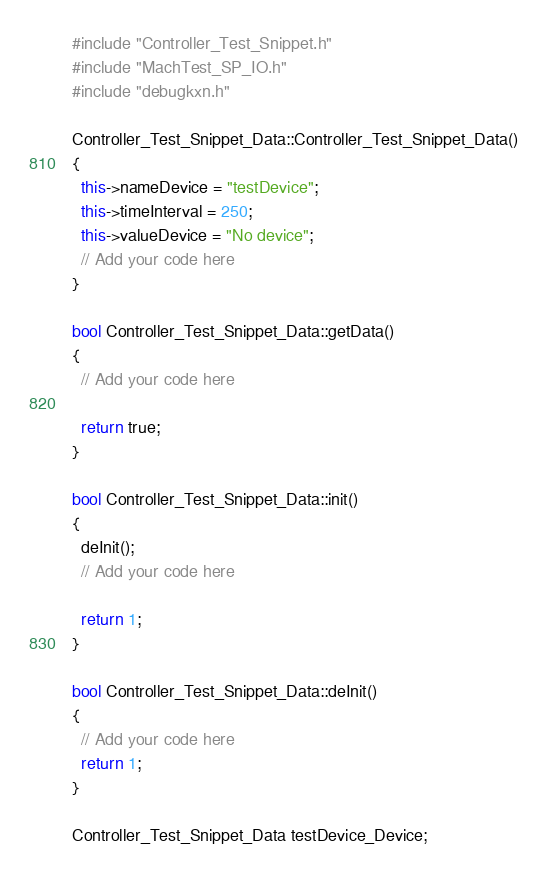<code> <loc_0><loc_0><loc_500><loc_500><_C++_>#include "Controller_Test_Snippet.h"
#include "MachTest_SP_IO.h"
#include "debugkxn.h"

Controller_Test_Snippet_Data::Controller_Test_Snippet_Data()
{
  this->nameDevice = "testDevice";
  this->timeInterval = 250;
  this->valueDevice = "No device";
  // Add your code here
}

bool Controller_Test_Snippet_Data::getData()
{
  // Add your code here
  
  return true;
}

bool Controller_Test_Snippet_Data::init()
{
  deInit();
  // Add your code here
  
  return 1;
}

bool Controller_Test_Snippet_Data::deInit()
{
  // Add your code here
  return 1;
}

Controller_Test_Snippet_Data testDevice_Device;</code> 